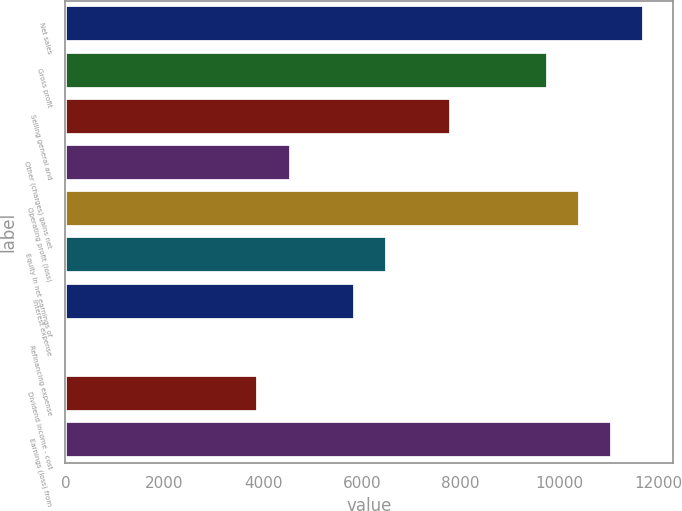<chart> <loc_0><loc_0><loc_500><loc_500><bar_chart><fcel>Net sales<fcel>Gross profit<fcel>Selling general and<fcel>Other (charges) gains net<fcel>Operating profit (loss)<fcel>Equity in net earnings of<fcel>Interest expense<fcel>Refinancing expense<fcel>Dividend income - cost<fcel>Earnings (loss) from<nl><fcel>11717.2<fcel>9764.5<fcel>7811.8<fcel>4557.3<fcel>10415.4<fcel>6510<fcel>5859.1<fcel>1<fcel>3906.4<fcel>11066.3<nl></chart> 